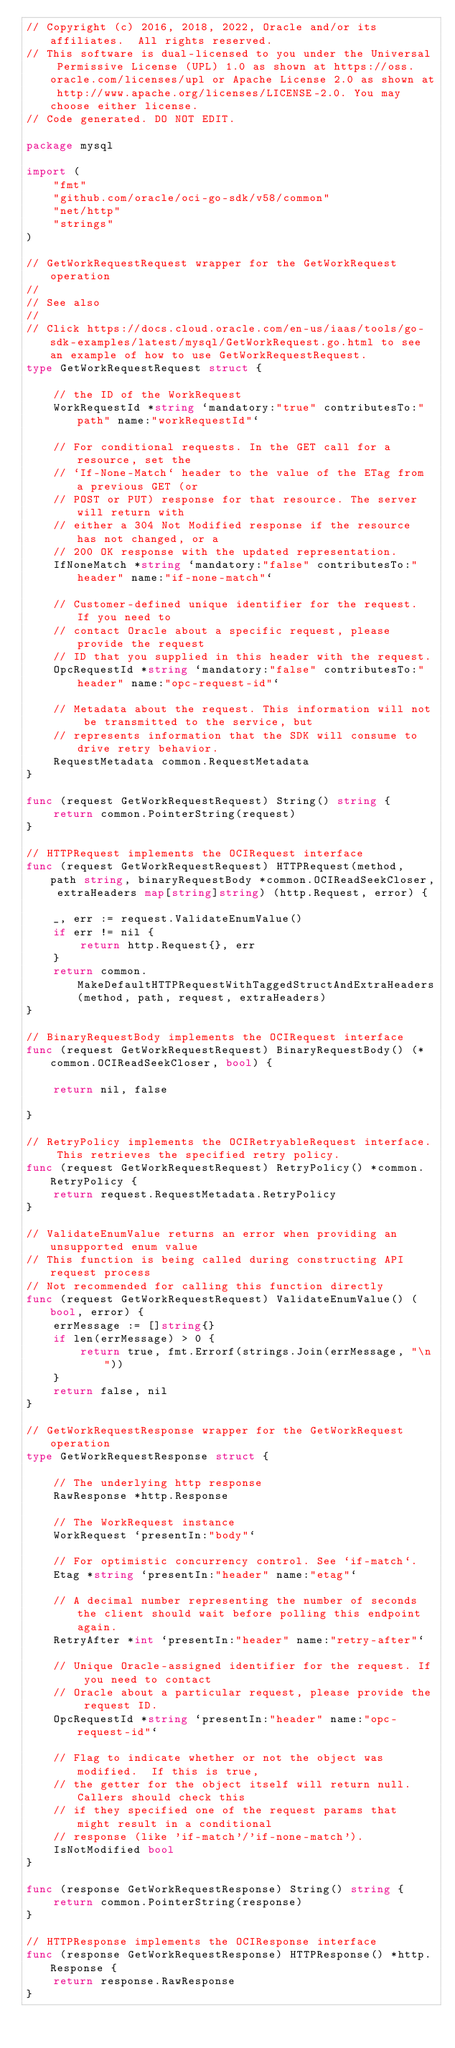Convert code to text. <code><loc_0><loc_0><loc_500><loc_500><_Go_>// Copyright (c) 2016, 2018, 2022, Oracle and/or its affiliates.  All rights reserved.
// This software is dual-licensed to you under the Universal Permissive License (UPL) 1.0 as shown at https://oss.oracle.com/licenses/upl or Apache License 2.0 as shown at http://www.apache.org/licenses/LICENSE-2.0. You may choose either license.
// Code generated. DO NOT EDIT.

package mysql

import (
	"fmt"
	"github.com/oracle/oci-go-sdk/v58/common"
	"net/http"
	"strings"
)

// GetWorkRequestRequest wrapper for the GetWorkRequest operation
//
// See also
//
// Click https://docs.cloud.oracle.com/en-us/iaas/tools/go-sdk-examples/latest/mysql/GetWorkRequest.go.html to see an example of how to use GetWorkRequestRequest.
type GetWorkRequestRequest struct {

	// the ID of the WorkRequest
	WorkRequestId *string `mandatory:"true" contributesTo:"path" name:"workRequestId"`

	// For conditional requests. In the GET call for a resource, set the
	// `If-None-Match` header to the value of the ETag from a previous GET (or
	// POST or PUT) response for that resource. The server will return with
	// either a 304 Not Modified response if the resource has not changed, or a
	// 200 OK response with the updated representation.
	IfNoneMatch *string `mandatory:"false" contributesTo:"header" name:"if-none-match"`

	// Customer-defined unique identifier for the request. If you need to
	// contact Oracle about a specific request, please provide the request
	// ID that you supplied in this header with the request.
	OpcRequestId *string `mandatory:"false" contributesTo:"header" name:"opc-request-id"`

	// Metadata about the request. This information will not be transmitted to the service, but
	// represents information that the SDK will consume to drive retry behavior.
	RequestMetadata common.RequestMetadata
}

func (request GetWorkRequestRequest) String() string {
	return common.PointerString(request)
}

// HTTPRequest implements the OCIRequest interface
func (request GetWorkRequestRequest) HTTPRequest(method, path string, binaryRequestBody *common.OCIReadSeekCloser, extraHeaders map[string]string) (http.Request, error) {

	_, err := request.ValidateEnumValue()
	if err != nil {
		return http.Request{}, err
	}
	return common.MakeDefaultHTTPRequestWithTaggedStructAndExtraHeaders(method, path, request, extraHeaders)
}

// BinaryRequestBody implements the OCIRequest interface
func (request GetWorkRequestRequest) BinaryRequestBody() (*common.OCIReadSeekCloser, bool) {

	return nil, false

}

// RetryPolicy implements the OCIRetryableRequest interface. This retrieves the specified retry policy.
func (request GetWorkRequestRequest) RetryPolicy() *common.RetryPolicy {
	return request.RequestMetadata.RetryPolicy
}

// ValidateEnumValue returns an error when providing an unsupported enum value
// This function is being called during constructing API request process
// Not recommended for calling this function directly
func (request GetWorkRequestRequest) ValidateEnumValue() (bool, error) {
	errMessage := []string{}
	if len(errMessage) > 0 {
		return true, fmt.Errorf(strings.Join(errMessage, "\n"))
	}
	return false, nil
}

// GetWorkRequestResponse wrapper for the GetWorkRequest operation
type GetWorkRequestResponse struct {

	// The underlying http response
	RawResponse *http.Response

	// The WorkRequest instance
	WorkRequest `presentIn:"body"`

	// For optimistic concurrency control. See `if-match`.
	Etag *string `presentIn:"header" name:"etag"`

	// A decimal number representing the number of seconds the client should wait before polling this endpoint again.
	RetryAfter *int `presentIn:"header" name:"retry-after"`

	// Unique Oracle-assigned identifier for the request. If you need to contact
	// Oracle about a particular request, please provide the request ID.
	OpcRequestId *string `presentIn:"header" name:"opc-request-id"`

	// Flag to indicate whether or not the object was modified.  If this is true,
	// the getter for the object itself will return null.  Callers should check this
	// if they specified one of the request params that might result in a conditional
	// response (like 'if-match'/'if-none-match').
	IsNotModified bool
}

func (response GetWorkRequestResponse) String() string {
	return common.PointerString(response)
}

// HTTPResponse implements the OCIResponse interface
func (response GetWorkRequestResponse) HTTPResponse() *http.Response {
	return response.RawResponse
}
</code> 